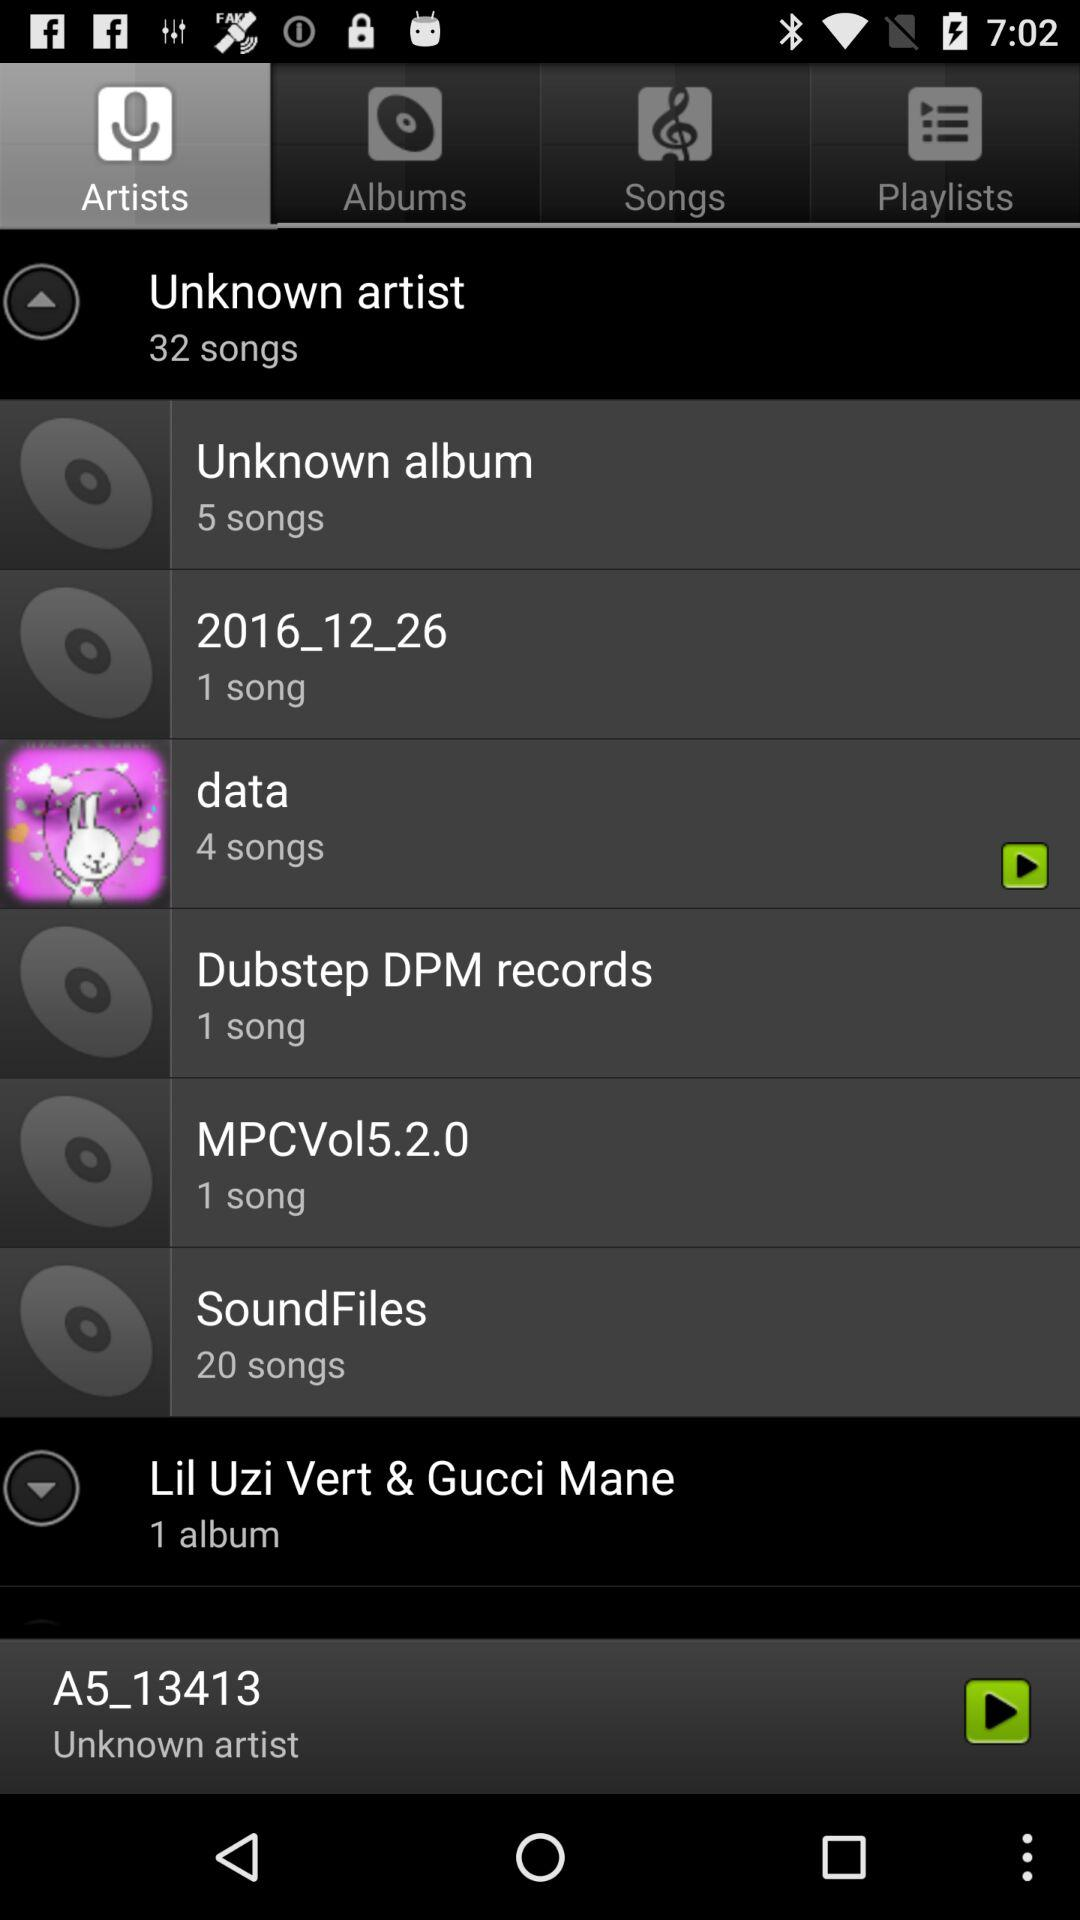How many songs are there in "data"? There are 4 songs. 